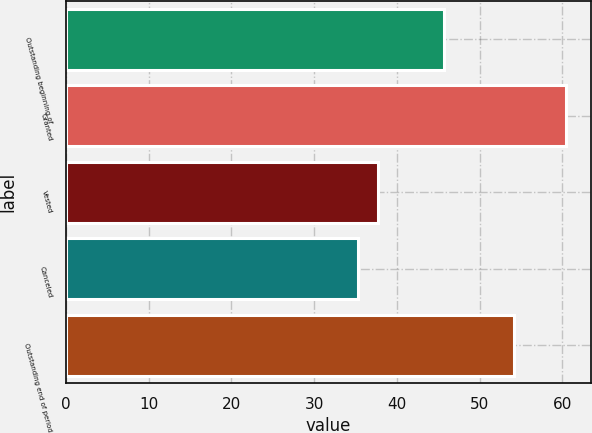<chart> <loc_0><loc_0><loc_500><loc_500><bar_chart><fcel>Outstanding beginning of<fcel>Granted<fcel>Vested<fcel>Canceled<fcel>Outstanding end of period<nl><fcel>45.72<fcel>60.48<fcel>37.77<fcel>35.25<fcel>54.16<nl></chart> 